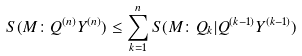Convert formula to latex. <formula><loc_0><loc_0><loc_500><loc_500>S ( M \colon Q ^ { ( n ) } Y ^ { ( n ) } ) \leq \sum _ { k = 1 } ^ { n } S ( M \colon Q _ { k } | Q ^ { ( k - 1 ) } Y ^ { ( k - 1 ) } )</formula> 